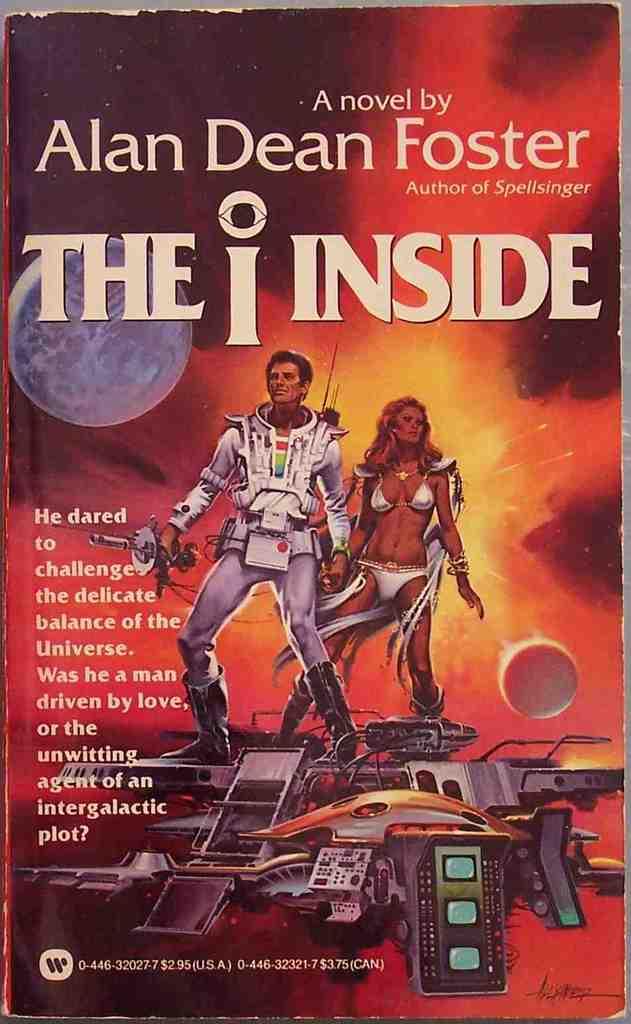What is the title of the book?
Make the answer very short. The i inside. 